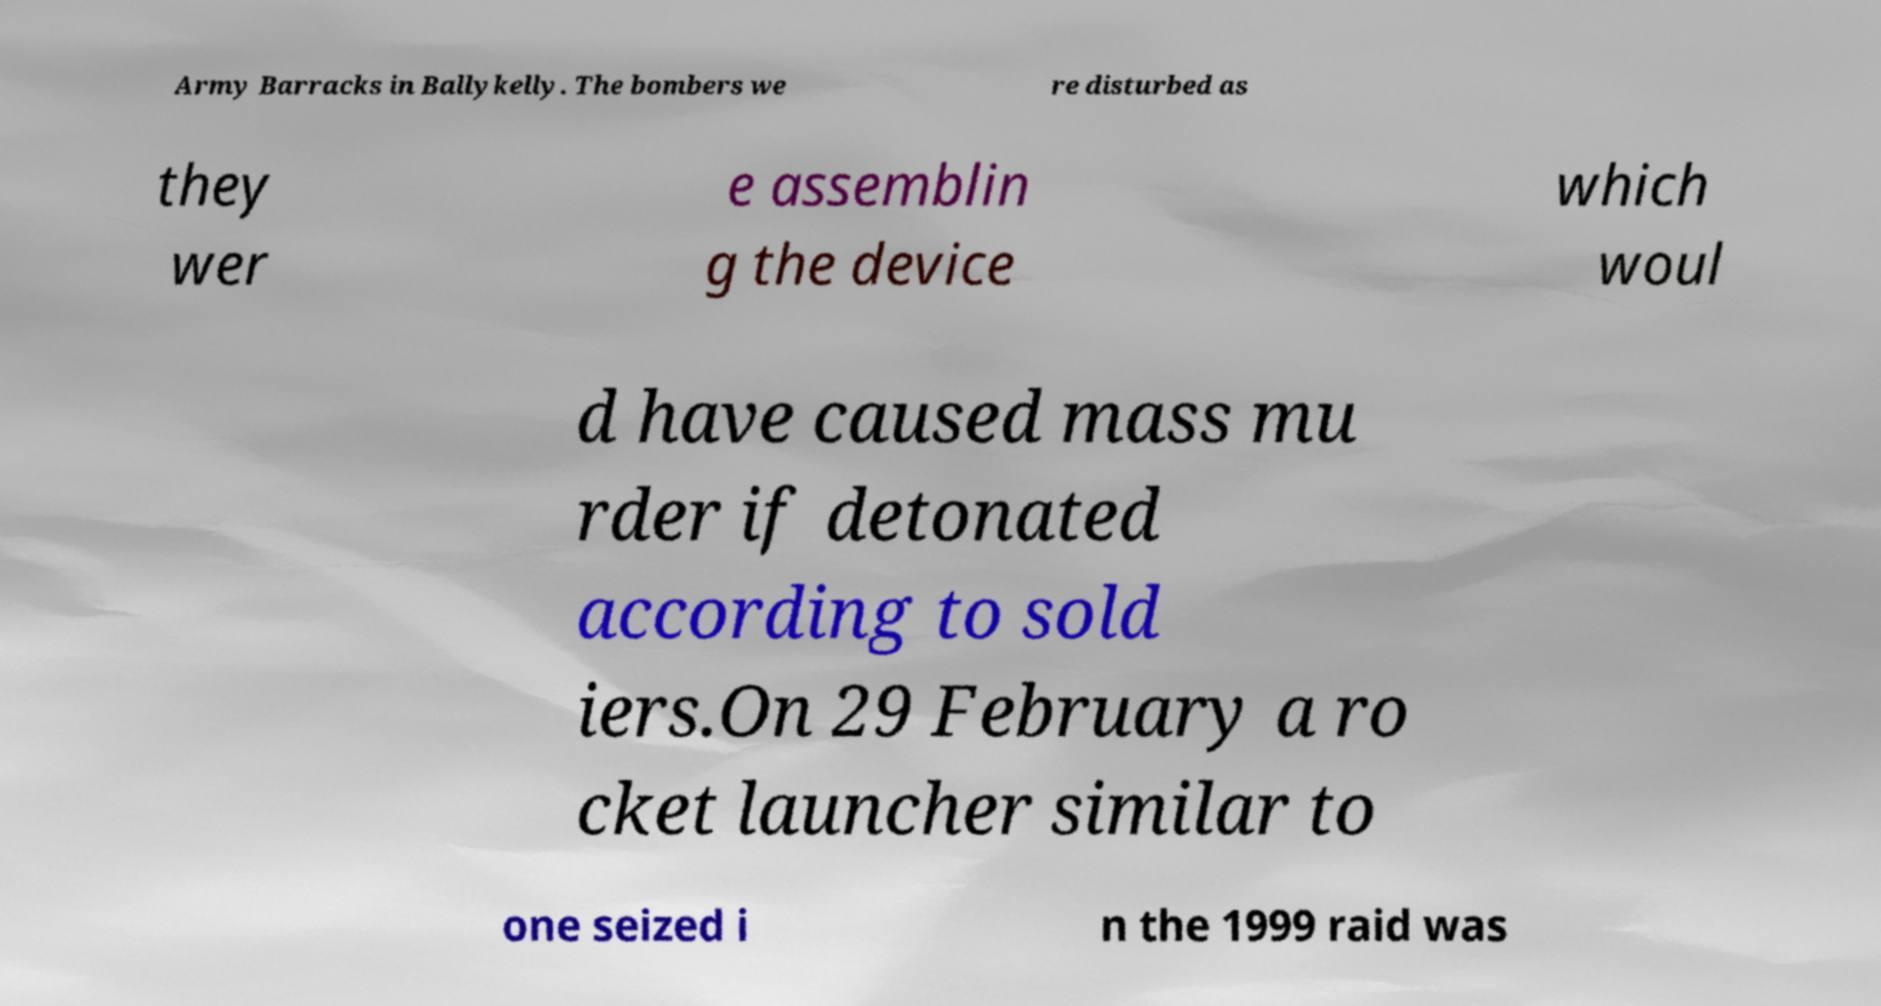Could you assist in decoding the text presented in this image and type it out clearly? Army Barracks in Ballykelly. The bombers we re disturbed as they wer e assemblin g the device which woul d have caused mass mu rder if detonated according to sold iers.On 29 February a ro cket launcher similar to one seized i n the 1999 raid was 